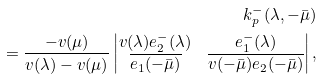<formula> <loc_0><loc_0><loc_500><loc_500>k ^ { - } _ { p } ( \lambda , - \bar { \mu } ) \\ = \frac { - v ( \mu ) } { v ( \lambda ) - v ( \mu ) } \left | \begin{matrix} v ( \lambda ) e _ { 2 } ^ { - } ( \lambda ) & e _ { 1 } ^ { - } ( \lambda ) \\ \overline { e _ { 1 } ( - \bar { \mu } ) } & \overline { v ( - \bar { \mu } ) e _ { 2 } ( - \bar { \mu } ) } \end{matrix} \right | ,</formula> 